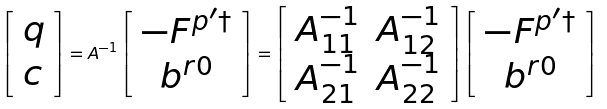<formula> <loc_0><loc_0><loc_500><loc_500>\left [ \begin{array} { l } q \\ c \end{array} \right ] = A ^ { - 1 } \left [ \begin{array} { c } - F ^ { p ^ { \prime } \dagger } \\ b ^ { r 0 } \end{array} \right ] = \left [ \begin{array} { l l } A ^ { - 1 } _ { 1 1 } & A ^ { - 1 } _ { 1 2 } \\ A ^ { - 1 } _ { 2 1 } & A ^ { - 1 } _ { 2 2 } \end{array} \right ] \left [ \begin{array} { c } - F ^ { p ^ { \prime } \dagger } \\ b ^ { r 0 } \end{array} \right ]</formula> 